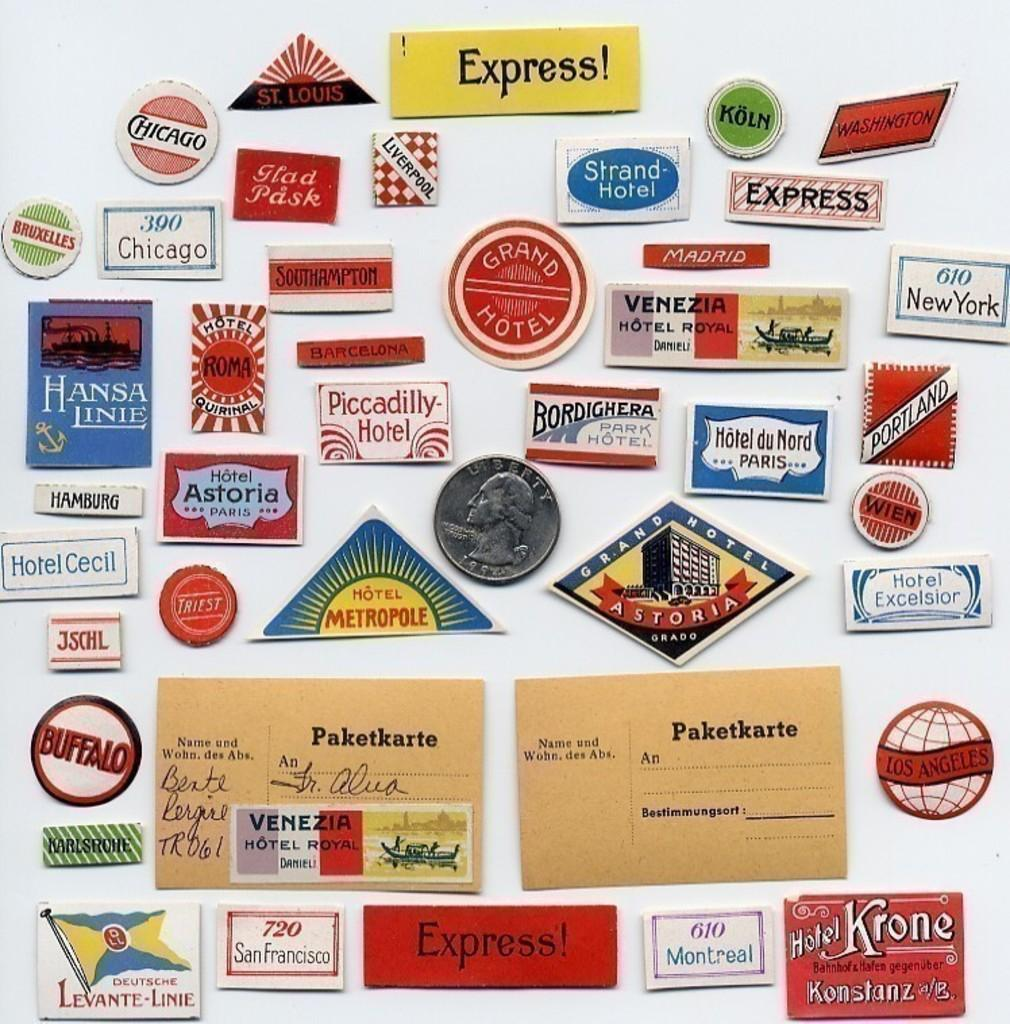<image>
Relay a brief, clear account of the picture shown. Stamps and postcards with a yellow stamp saying "Express!". 